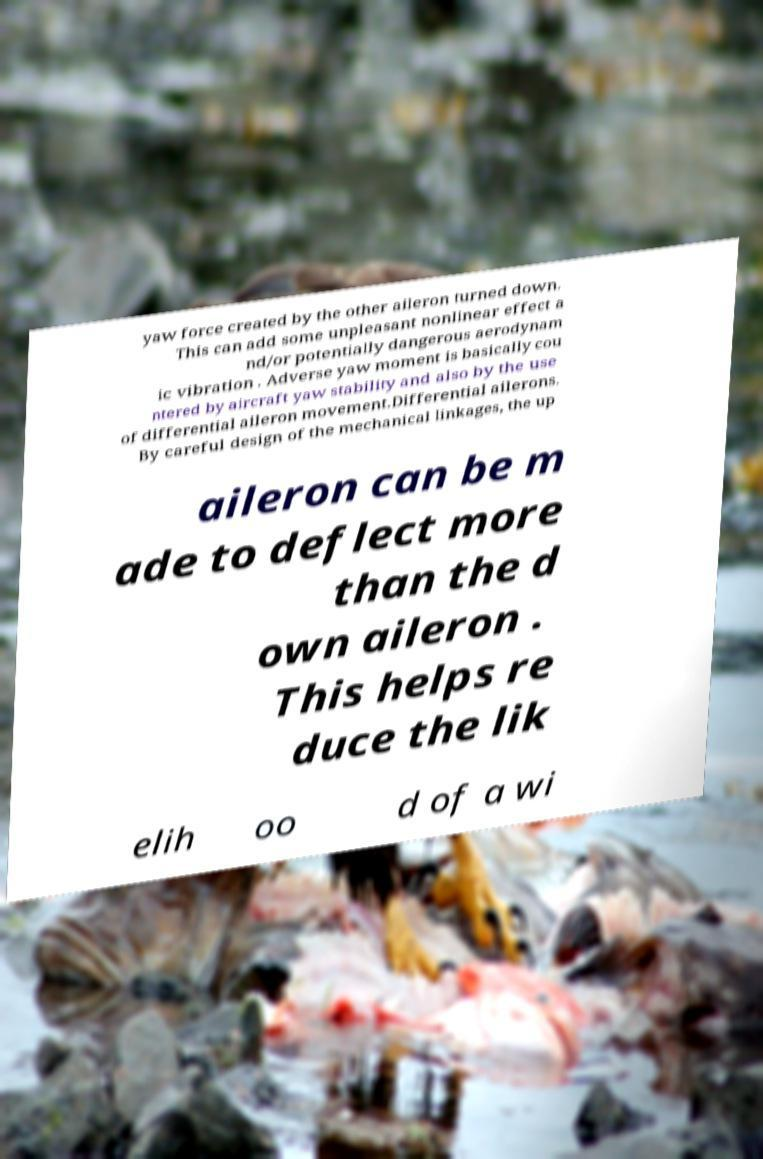Please identify and transcribe the text found in this image. yaw force created by the other aileron turned down. This can add some unpleasant nonlinear effect a nd/or potentially dangerous aerodynam ic vibration . Adverse yaw moment is basically cou ntered by aircraft yaw stability and also by the use of differential aileron movement.Differential ailerons. By careful design of the mechanical linkages, the up aileron can be m ade to deflect more than the d own aileron . This helps re duce the lik elih oo d of a wi 